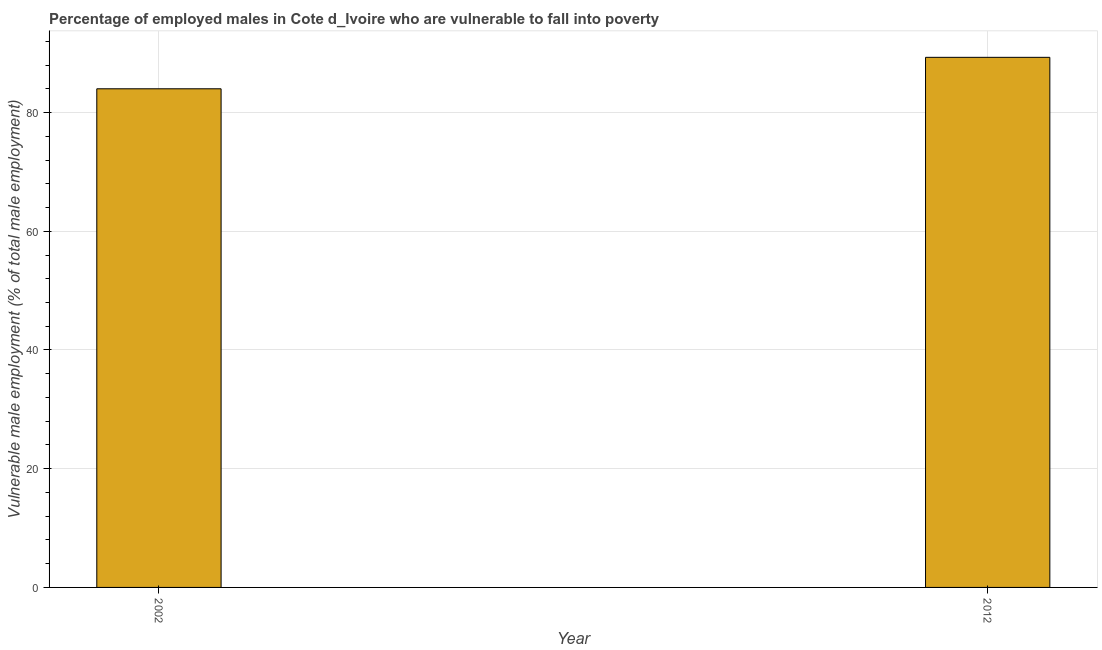Does the graph contain any zero values?
Your answer should be compact. No. What is the title of the graph?
Offer a terse response. Percentage of employed males in Cote d_Ivoire who are vulnerable to fall into poverty. What is the label or title of the X-axis?
Your response must be concise. Year. What is the label or title of the Y-axis?
Your answer should be very brief. Vulnerable male employment (% of total male employment). Across all years, what is the maximum percentage of employed males who are vulnerable to fall into poverty?
Offer a very short reply. 89.3. In which year was the percentage of employed males who are vulnerable to fall into poverty maximum?
Provide a short and direct response. 2012. What is the sum of the percentage of employed males who are vulnerable to fall into poverty?
Make the answer very short. 173.3. What is the average percentage of employed males who are vulnerable to fall into poverty per year?
Provide a succinct answer. 86.65. What is the median percentage of employed males who are vulnerable to fall into poverty?
Make the answer very short. 86.65. In how many years, is the percentage of employed males who are vulnerable to fall into poverty greater than 24 %?
Offer a very short reply. 2. What is the ratio of the percentage of employed males who are vulnerable to fall into poverty in 2002 to that in 2012?
Provide a succinct answer. 0.94. Is the percentage of employed males who are vulnerable to fall into poverty in 2002 less than that in 2012?
Make the answer very short. Yes. In how many years, is the percentage of employed males who are vulnerable to fall into poverty greater than the average percentage of employed males who are vulnerable to fall into poverty taken over all years?
Your answer should be compact. 1. How many bars are there?
Your answer should be very brief. 2. What is the difference between two consecutive major ticks on the Y-axis?
Make the answer very short. 20. What is the Vulnerable male employment (% of total male employment) in 2002?
Offer a very short reply. 84. What is the Vulnerable male employment (% of total male employment) in 2012?
Your response must be concise. 89.3. What is the difference between the Vulnerable male employment (% of total male employment) in 2002 and 2012?
Ensure brevity in your answer.  -5.3. What is the ratio of the Vulnerable male employment (% of total male employment) in 2002 to that in 2012?
Your answer should be very brief. 0.94. 